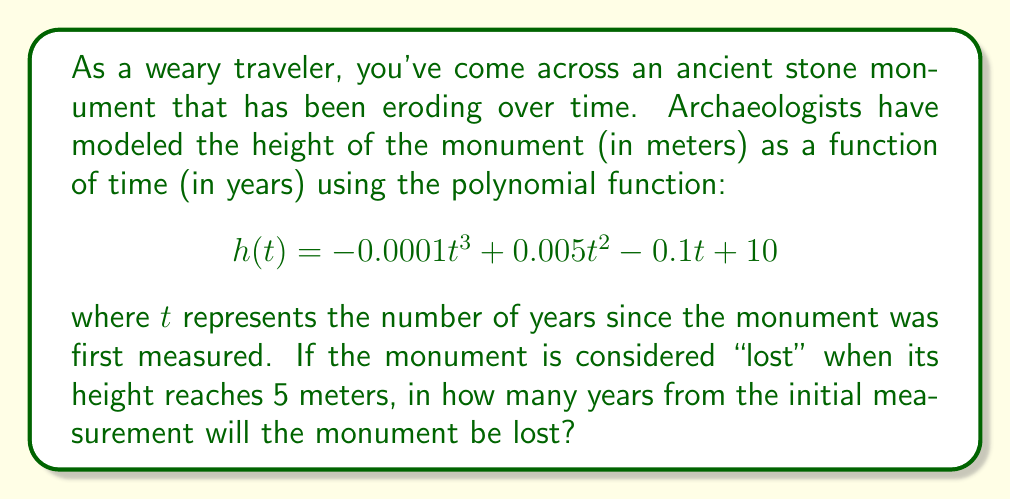Solve this math problem. To solve this problem, we need to find the value of $t$ when $h(t) = 5$. Let's approach this step-by-step:

1) We start with the equation:
   $$-0.0001t^3 + 0.005t^2 - 0.1t + 10 = 5$$

2) Subtract 5 from both sides:
   $$-0.0001t^3 + 0.005t^2 - 0.1t + 5 = 0$$

3) This is a cubic equation. While it can be solved analytically, the process is complex. In practice, we would use numerical methods or a graphing calculator to find the solution.

4) Using a graphing calculator or computer algebra system, we find that this equation has three roots:
   $t_1 \approx 50.95$, $t_2 \approx 161.71$, and $t_3 \approx -212.66$

5) Since time cannot be negative in this context, we can discard the negative root.

6) The smaller positive root, $t \approx 50.95$ years, represents when the monument's height first reaches 5 meters.

7) Round to the nearest whole year, as it's more practical for this scenario.

Therefore, the monument will be considered "lost" approximately 51 years after the initial measurement.
Answer: 51 years 